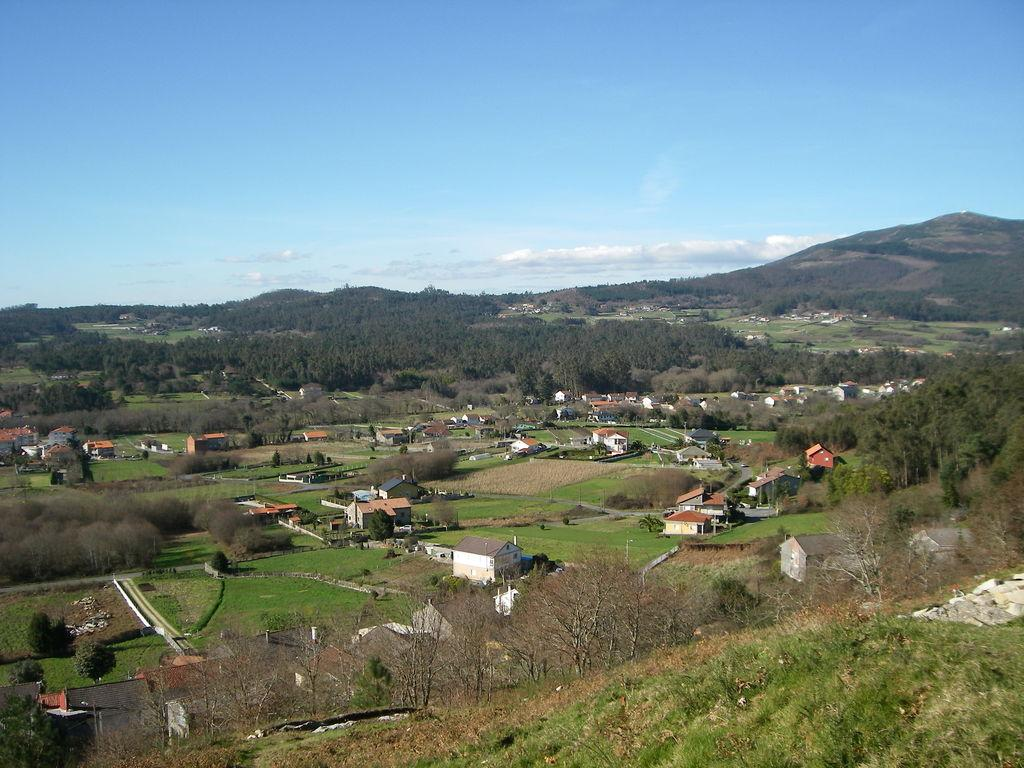What type of structures are present in the image? There are houses in the image. What type of vegetation can be seen in the image? There are trees in the image. What natural feature is visible in the background of the image? There are mountains visible in the background of the image. What is the condition of the sky in the background of the image? The sky is clear in the background of the image. How many legs does the toy in the image have? There is no toy present in the image, so it is not possible to determine how many legs it might have. 